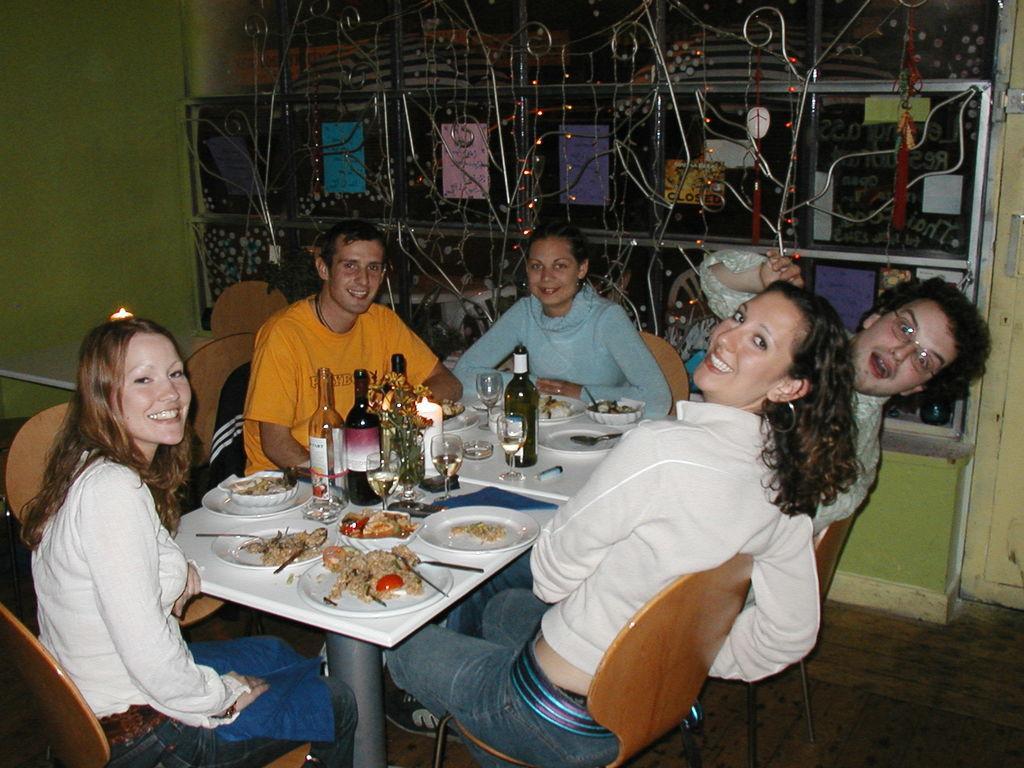Can you describe this image briefly? This a picture consist of a group of a person sitting around the table they are smiling and in front the them there is a table , on the table there is a bottle ,glass,spoon kept on t able and a food kept on the plate,back side there is a colorful window. seem and there are some chairs visible. 